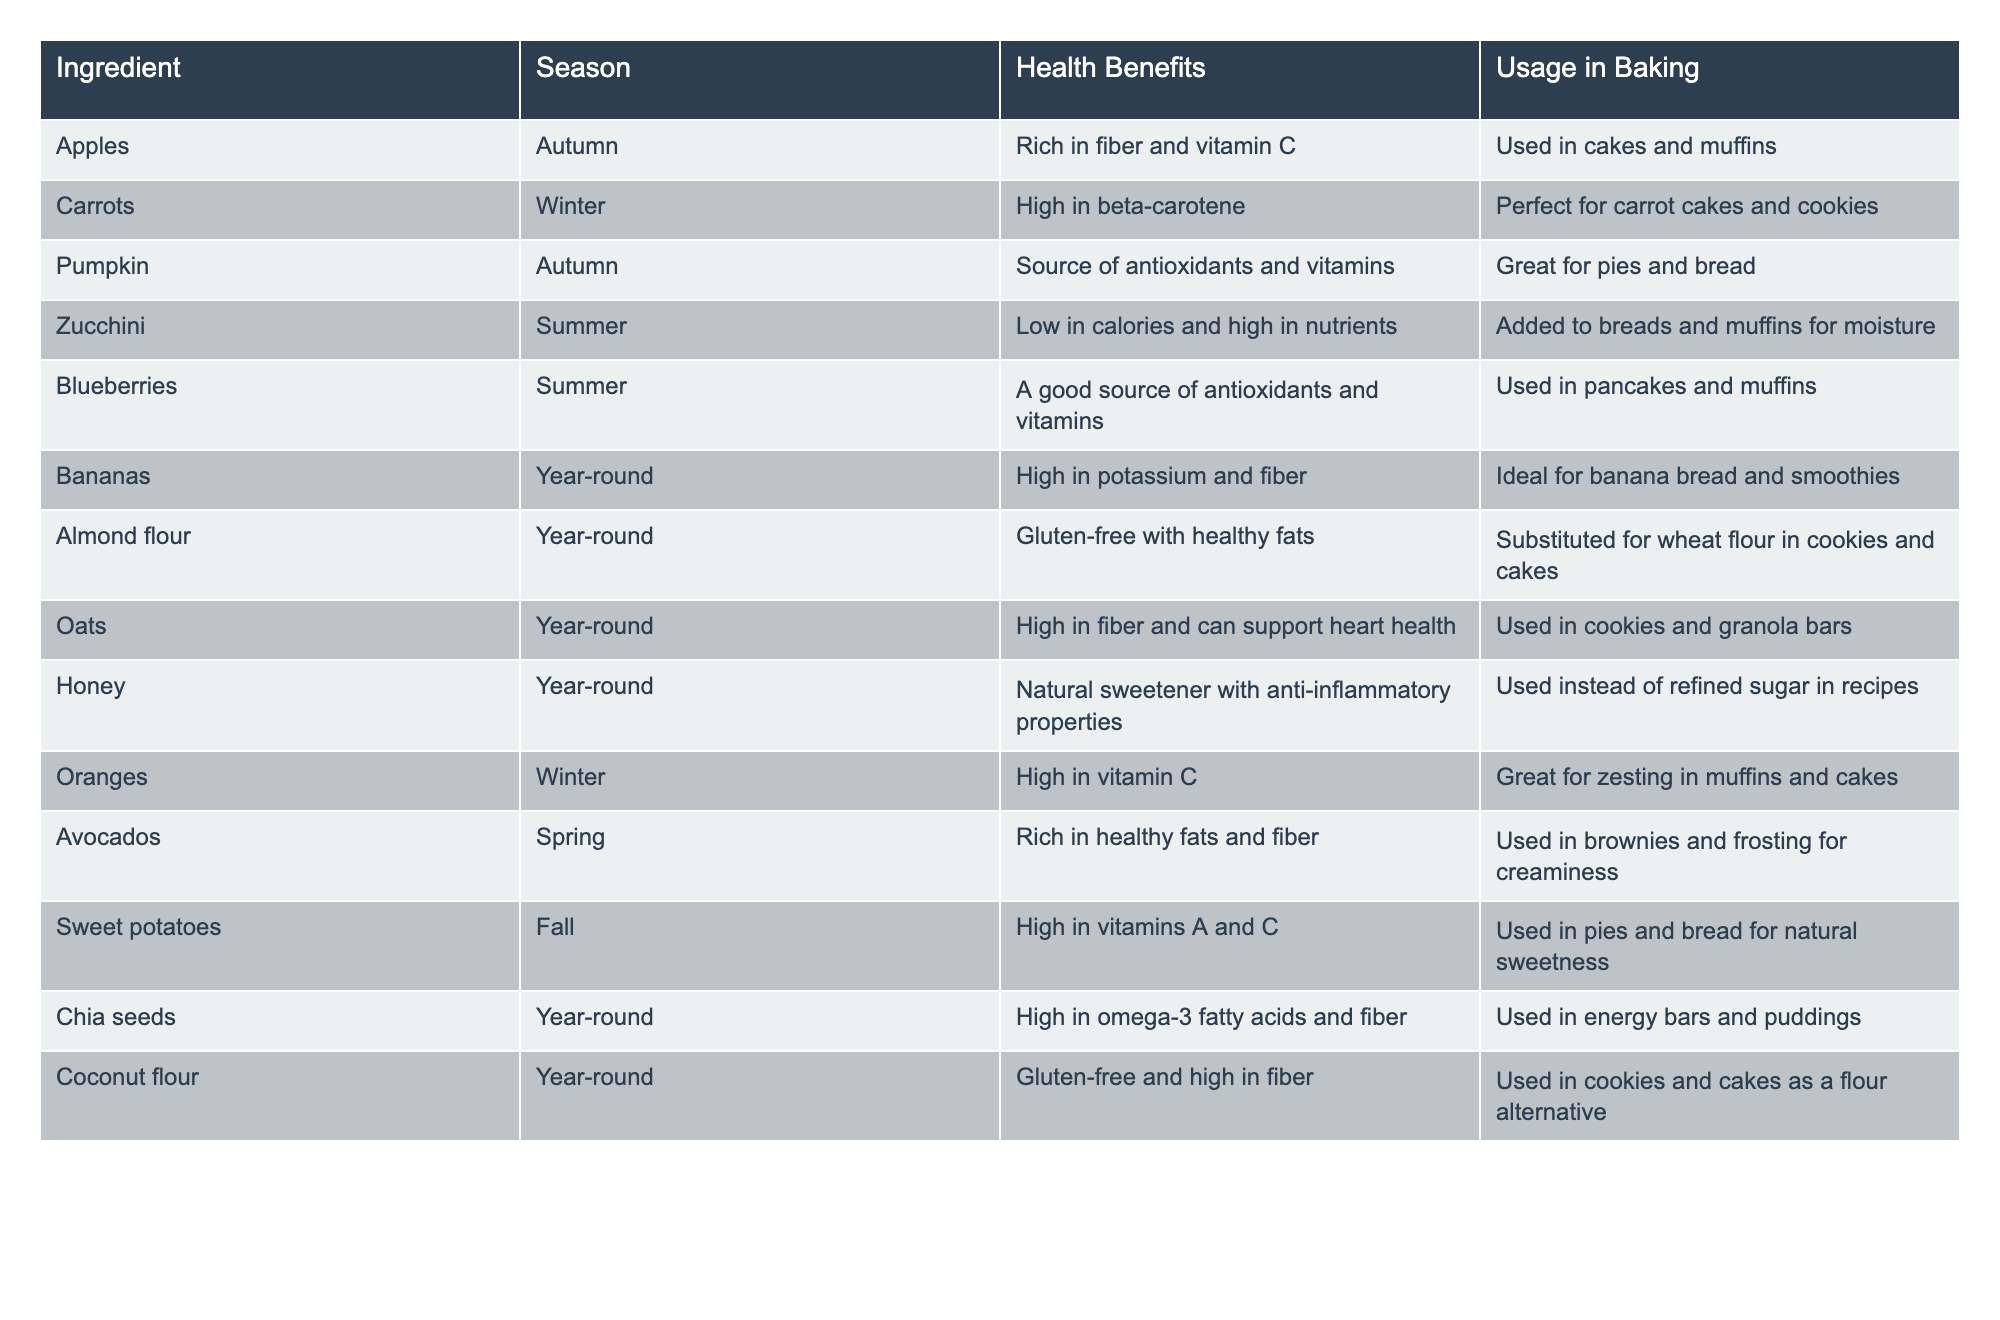What season is best for baking with pumpkins? According to the table, pumpkins are available in autumn, as indicated in the 'Season' column next to 'Pumpkin.'
Answer: Autumn Which ingredient provide high levels of potassium? The table shows that bananas are high in potassium, which is specified in the 'Health Benefits' column next to bananas.
Answer: Bananas How many ingredients are available year-round? From the table, we can count the ingredients listed under the 'Year-round' season: there are six ingredients (bananas, almond flour, oats, honey, chia seeds, and coconut flour).
Answer: 6 Which ingredient can be used in both cookies and cakes? The table states that almond flour can be substituted for wheat flour in cookies and cakes, making it usable in both types of baked goods.
Answer: Almond flour Is zucchini low in calories? The table indicates that zucchini is low in calories, which is directly stated in the 'Health Benefits’ column.
Answer: Yes What are the health benefits of using chia seeds in recipes? According to the table, chia seeds are high in omega-3 fatty acids and fiber, which are mentioned in the 'Health Benefits' column alongside chia seeds.
Answer: High in omega-3 fatty acids and fiber If I want to make a seasonal carrot cake, which season should I choose? The table lists carrots under the 'Winter' season and specifies their usage in carrot cakes, which means winter is the correct choice for a seasonal carrot cake.
Answer: Winter Which two ingredients can be used for natural sweetness in baking? The table lists sweet potatoes and honey, both of which are indicated as providing natural sweetness in the 'Usage in Baking' column.
Answer: Sweet potatoes and honey In which recipes are blueberries typically used? The table shows that blueberries are used in pancakes and muffins as noted in the 'Usage in Baking' column, indicating their common recipes.
Answer: Pancakes and muffins Are there any gluten-free baking options listed? The table specifies almond flour and coconut flour as gluten-free options, which are noted in their respective 'Health Benefits' sections.
Answer: Yes, almond flour and coconut flour Which ingredient has the highest seasonal variability? The table shows that there is no ingredient listed under more than one season other than the year-round options; thus, the ingredients vary by being available only in specific seasons. This indicates seasonal variability based on those lined under individual seasons.
Answer: Variable based on seasons 